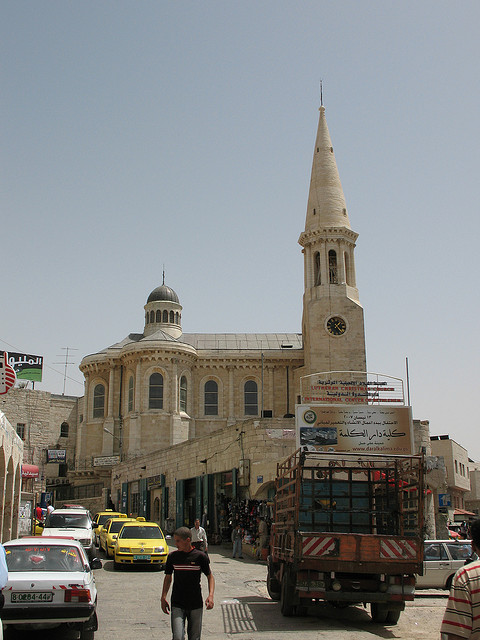<image>What company name is on the bus? There is no bus in the image. Therefore, the company name cannot be determined. What company name is on the bus? I don't know what company name is on the bus. It is not clear from the image. 